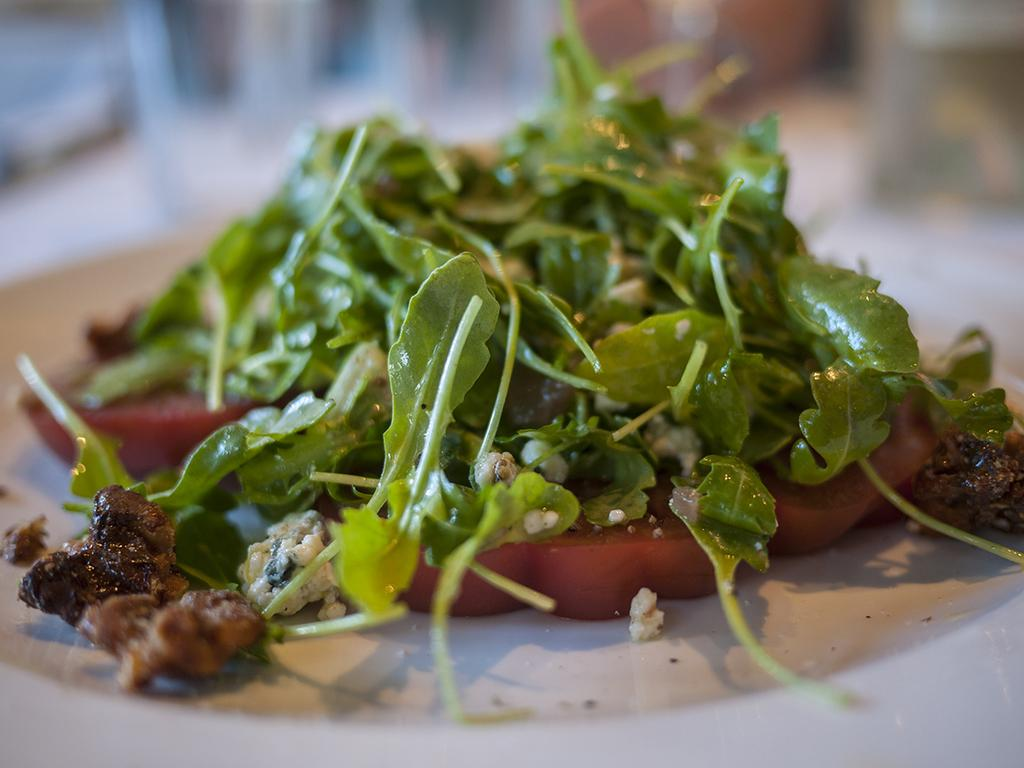What is on the plate that is visible in the image? There is food in a plate in the image. Where is the plate located in the image? The plate is placed on a table. What color is the crayon used to draw on the table in the image? There is no crayon or drawing present on the table in the image. 